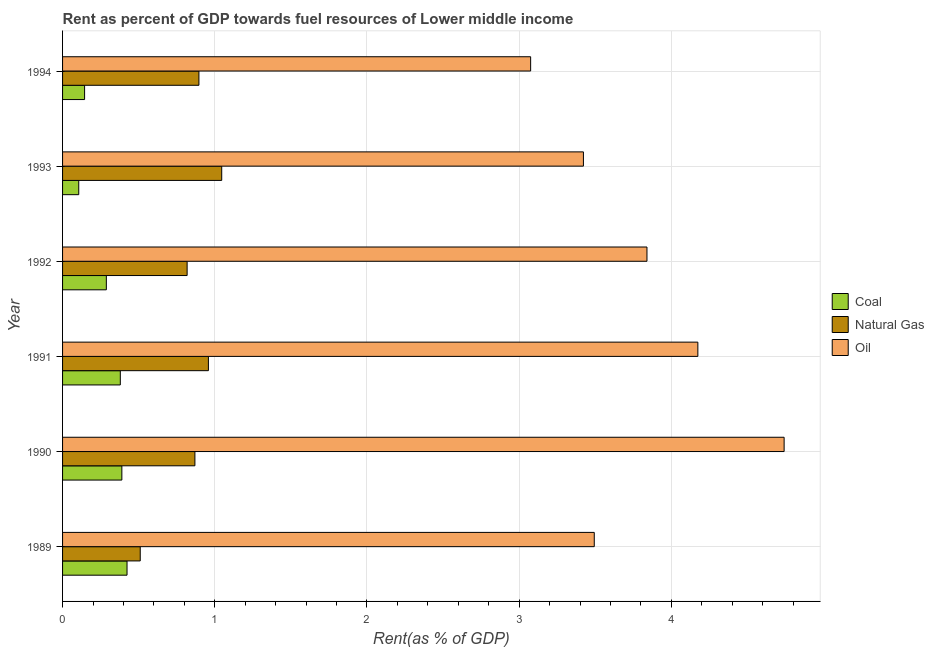In how many cases, is the number of bars for a given year not equal to the number of legend labels?
Keep it short and to the point. 0. What is the rent towards oil in 1992?
Offer a very short reply. 3.84. Across all years, what is the maximum rent towards oil?
Your response must be concise. 4.74. Across all years, what is the minimum rent towards coal?
Your answer should be compact. 0.11. What is the total rent towards coal in the graph?
Offer a terse response. 1.73. What is the difference between the rent towards natural gas in 1991 and that in 1993?
Your answer should be very brief. -0.09. What is the difference between the rent towards coal in 1989 and the rent towards natural gas in 1990?
Offer a very short reply. -0.45. In the year 1993, what is the difference between the rent towards natural gas and rent towards coal?
Provide a short and direct response. 0.94. What is the ratio of the rent towards coal in 1990 to that in 1994?
Your answer should be compact. 2.69. Is the rent towards oil in 1990 less than that in 1992?
Provide a succinct answer. No. Is the difference between the rent towards oil in 1990 and 1993 greater than the difference between the rent towards natural gas in 1990 and 1993?
Make the answer very short. Yes. What is the difference between the highest and the second highest rent towards oil?
Keep it short and to the point. 0.57. What is the difference between the highest and the lowest rent towards oil?
Give a very brief answer. 1.67. Is the sum of the rent towards coal in 1991 and 1992 greater than the maximum rent towards oil across all years?
Your answer should be very brief. No. What does the 1st bar from the top in 1994 represents?
Offer a very short reply. Oil. What does the 2nd bar from the bottom in 1992 represents?
Provide a short and direct response. Natural Gas. Is it the case that in every year, the sum of the rent towards coal and rent towards natural gas is greater than the rent towards oil?
Provide a succinct answer. No. How many bars are there?
Your response must be concise. 18. How many years are there in the graph?
Give a very brief answer. 6. What is the difference between two consecutive major ticks on the X-axis?
Ensure brevity in your answer.  1. Does the graph contain grids?
Give a very brief answer. Yes. Where does the legend appear in the graph?
Offer a terse response. Center right. How are the legend labels stacked?
Your answer should be compact. Vertical. What is the title of the graph?
Your answer should be very brief. Rent as percent of GDP towards fuel resources of Lower middle income. Does "Travel services" appear as one of the legend labels in the graph?
Provide a short and direct response. No. What is the label or title of the X-axis?
Offer a terse response. Rent(as % of GDP). What is the Rent(as % of GDP) in Coal in 1989?
Your answer should be very brief. 0.42. What is the Rent(as % of GDP) in Natural Gas in 1989?
Provide a short and direct response. 0.51. What is the Rent(as % of GDP) in Oil in 1989?
Your answer should be very brief. 3.49. What is the Rent(as % of GDP) in Coal in 1990?
Offer a very short reply. 0.39. What is the Rent(as % of GDP) in Natural Gas in 1990?
Provide a short and direct response. 0.87. What is the Rent(as % of GDP) in Oil in 1990?
Give a very brief answer. 4.74. What is the Rent(as % of GDP) of Coal in 1991?
Your answer should be compact. 0.38. What is the Rent(as % of GDP) of Natural Gas in 1991?
Ensure brevity in your answer.  0.96. What is the Rent(as % of GDP) in Oil in 1991?
Ensure brevity in your answer.  4.17. What is the Rent(as % of GDP) of Coal in 1992?
Give a very brief answer. 0.29. What is the Rent(as % of GDP) in Natural Gas in 1992?
Provide a succinct answer. 0.82. What is the Rent(as % of GDP) of Oil in 1992?
Ensure brevity in your answer.  3.84. What is the Rent(as % of GDP) of Coal in 1993?
Ensure brevity in your answer.  0.11. What is the Rent(as % of GDP) of Natural Gas in 1993?
Your answer should be compact. 1.05. What is the Rent(as % of GDP) in Oil in 1993?
Ensure brevity in your answer.  3.42. What is the Rent(as % of GDP) in Coal in 1994?
Your response must be concise. 0.14. What is the Rent(as % of GDP) in Natural Gas in 1994?
Provide a succinct answer. 0.9. What is the Rent(as % of GDP) of Oil in 1994?
Ensure brevity in your answer.  3.08. Across all years, what is the maximum Rent(as % of GDP) of Coal?
Provide a succinct answer. 0.42. Across all years, what is the maximum Rent(as % of GDP) in Natural Gas?
Provide a short and direct response. 1.05. Across all years, what is the maximum Rent(as % of GDP) of Oil?
Your response must be concise. 4.74. Across all years, what is the minimum Rent(as % of GDP) of Coal?
Offer a very short reply. 0.11. Across all years, what is the minimum Rent(as % of GDP) in Natural Gas?
Your response must be concise. 0.51. Across all years, what is the minimum Rent(as % of GDP) of Oil?
Your response must be concise. 3.08. What is the total Rent(as % of GDP) of Coal in the graph?
Ensure brevity in your answer.  1.73. What is the total Rent(as % of GDP) in Natural Gas in the graph?
Give a very brief answer. 5.1. What is the total Rent(as % of GDP) in Oil in the graph?
Offer a terse response. 22.75. What is the difference between the Rent(as % of GDP) in Coal in 1989 and that in 1990?
Offer a terse response. 0.03. What is the difference between the Rent(as % of GDP) of Natural Gas in 1989 and that in 1990?
Give a very brief answer. -0.36. What is the difference between the Rent(as % of GDP) of Oil in 1989 and that in 1990?
Make the answer very short. -1.25. What is the difference between the Rent(as % of GDP) in Coal in 1989 and that in 1991?
Provide a short and direct response. 0.04. What is the difference between the Rent(as % of GDP) of Natural Gas in 1989 and that in 1991?
Offer a very short reply. -0.45. What is the difference between the Rent(as % of GDP) of Oil in 1989 and that in 1991?
Provide a short and direct response. -0.68. What is the difference between the Rent(as % of GDP) in Coal in 1989 and that in 1992?
Offer a terse response. 0.14. What is the difference between the Rent(as % of GDP) of Natural Gas in 1989 and that in 1992?
Keep it short and to the point. -0.31. What is the difference between the Rent(as % of GDP) in Oil in 1989 and that in 1992?
Provide a short and direct response. -0.35. What is the difference between the Rent(as % of GDP) of Coal in 1989 and that in 1993?
Ensure brevity in your answer.  0.32. What is the difference between the Rent(as % of GDP) in Natural Gas in 1989 and that in 1993?
Ensure brevity in your answer.  -0.54. What is the difference between the Rent(as % of GDP) of Oil in 1989 and that in 1993?
Provide a short and direct response. 0.07. What is the difference between the Rent(as % of GDP) in Coal in 1989 and that in 1994?
Your answer should be very brief. 0.28. What is the difference between the Rent(as % of GDP) of Natural Gas in 1989 and that in 1994?
Your answer should be very brief. -0.39. What is the difference between the Rent(as % of GDP) in Oil in 1989 and that in 1994?
Offer a very short reply. 0.42. What is the difference between the Rent(as % of GDP) in Coal in 1990 and that in 1991?
Ensure brevity in your answer.  0.01. What is the difference between the Rent(as % of GDP) in Natural Gas in 1990 and that in 1991?
Your answer should be very brief. -0.09. What is the difference between the Rent(as % of GDP) in Oil in 1990 and that in 1991?
Provide a succinct answer. 0.57. What is the difference between the Rent(as % of GDP) of Coal in 1990 and that in 1992?
Make the answer very short. 0.1. What is the difference between the Rent(as % of GDP) of Natural Gas in 1990 and that in 1992?
Ensure brevity in your answer.  0.05. What is the difference between the Rent(as % of GDP) in Oil in 1990 and that in 1992?
Your response must be concise. 0.9. What is the difference between the Rent(as % of GDP) of Coal in 1990 and that in 1993?
Provide a succinct answer. 0.28. What is the difference between the Rent(as % of GDP) in Natural Gas in 1990 and that in 1993?
Your response must be concise. -0.18. What is the difference between the Rent(as % of GDP) of Oil in 1990 and that in 1993?
Provide a short and direct response. 1.32. What is the difference between the Rent(as % of GDP) of Coal in 1990 and that in 1994?
Offer a terse response. 0.24. What is the difference between the Rent(as % of GDP) of Natural Gas in 1990 and that in 1994?
Offer a very short reply. -0.03. What is the difference between the Rent(as % of GDP) of Oil in 1990 and that in 1994?
Provide a succinct answer. 1.67. What is the difference between the Rent(as % of GDP) of Coal in 1991 and that in 1992?
Provide a short and direct response. 0.09. What is the difference between the Rent(as % of GDP) in Natural Gas in 1991 and that in 1992?
Offer a very short reply. 0.14. What is the difference between the Rent(as % of GDP) in Oil in 1991 and that in 1992?
Offer a very short reply. 0.33. What is the difference between the Rent(as % of GDP) of Coal in 1991 and that in 1993?
Offer a very short reply. 0.27. What is the difference between the Rent(as % of GDP) in Natural Gas in 1991 and that in 1993?
Offer a terse response. -0.09. What is the difference between the Rent(as % of GDP) in Oil in 1991 and that in 1993?
Keep it short and to the point. 0.75. What is the difference between the Rent(as % of GDP) of Coal in 1991 and that in 1994?
Make the answer very short. 0.23. What is the difference between the Rent(as % of GDP) in Natural Gas in 1991 and that in 1994?
Ensure brevity in your answer.  0.06. What is the difference between the Rent(as % of GDP) of Oil in 1991 and that in 1994?
Give a very brief answer. 1.1. What is the difference between the Rent(as % of GDP) of Coal in 1992 and that in 1993?
Provide a succinct answer. 0.18. What is the difference between the Rent(as % of GDP) of Natural Gas in 1992 and that in 1993?
Your response must be concise. -0.23. What is the difference between the Rent(as % of GDP) in Oil in 1992 and that in 1993?
Your answer should be very brief. 0.42. What is the difference between the Rent(as % of GDP) of Coal in 1992 and that in 1994?
Make the answer very short. 0.14. What is the difference between the Rent(as % of GDP) in Natural Gas in 1992 and that in 1994?
Make the answer very short. -0.08. What is the difference between the Rent(as % of GDP) in Oil in 1992 and that in 1994?
Your answer should be very brief. 0.76. What is the difference between the Rent(as % of GDP) in Coal in 1993 and that in 1994?
Make the answer very short. -0.04. What is the difference between the Rent(as % of GDP) of Natural Gas in 1993 and that in 1994?
Offer a terse response. 0.15. What is the difference between the Rent(as % of GDP) of Oil in 1993 and that in 1994?
Make the answer very short. 0.35. What is the difference between the Rent(as % of GDP) of Coal in 1989 and the Rent(as % of GDP) of Natural Gas in 1990?
Provide a succinct answer. -0.45. What is the difference between the Rent(as % of GDP) in Coal in 1989 and the Rent(as % of GDP) in Oil in 1990?
Provide a succinct answer. -4.32. What is the difference between the Rent(as % of GDP) in Natural Gas in 1989 and the Rent(as % of GDP) in Oil in 1990?
Your answer should be very brief. -4.23. What is the difference between the Rent(as % of GDP) of Coal in 1989 and the Rent(as % of GDP) of Natural Gas in 1991?
Provide a succinct answer. -0.53. What is the difference between the Rent(as % of GDP) of Coal in 1989 and the Rent(as % of GDP) of Oil in 1991?
Keep it short and to the point. -3.75. What is the difference between the Rent(as % of GDP) in Natural Gas in 1989 and the Rent(as % of GDP) in Oil in 1991?
Your answer should be very brief. -3.66. What is the difference between the Rent(as % of GDP) in Coal in 1989 and the Rent(as % of GDP) in Natural Gas in 1992?
Your answer should be very brief. -0.39. What is the difference between the Rent(as % of GDP) of Coal in 1989 and the Rent(as % of GDP) of Oil in 1992?
Offer a terse response. -3.42. What is the difference between the Rent(as % of GDP) of Natural Gas in 1989 and the Rent(as % of GDP) of Oil in 1992?
Your answer should be compact. -3.33. What is the difference between the Rent(as % of GDP) in Coal in 1989 and the Rent(as % of GDP) in Natural Gas in 1993?
Your answer should be compact. -0.62. What is the difference between the Rent(as % of GDP) in Coal in 1989 and the Rent(as % of GDP) in Oil in 1993?
Offer a very short reply. -3. What is the difference between the Rent(as % of GDP) of Natural Gas in 1989 and the Rent(as % of GDP) of Oil in 1993?
Offer a very short reply. -2.91. What is the difference between the Rent(as % of GDP) of Coal in 1989 and the Rent(as % of GDP) of Natural Gas in 1994?
Your answer should be compact. -0.47. What is the difference between the Rent(as % of GDP) of Coal in 1989 and the Rent(as % of GDP) of Oil in 1994?
Offer a very short reply. -2.65. What is the difference between the Rent(as % of GDP) in Natural Gas in 1989 and the Rent(as % of GDP) in Oil in 1994?
Offer a very short reply. -2.56. What is the difference between the Rent(as % of GDP) in Coal in 1990 and the Rent(as % of GDP) in Natural Gas in 1991?
Your answer should be compact. -0.57. What is the difference between the Rent(as % of GDP) of Coal in 1990 and the Rent(as % of GDP) of Oil in 1991?
Make the answer very short. -3.78. What is the difference between the Rent(as % of GDP) of Natural Gas in 1990 and the Rent(as % of GDP) of Oil in 1991?
Ensure brevity in your answer.  -3.3. What is the difference between the Rent(as % of GDP) of Coal in 1990 and the Rent(as % of GDP) of Natural Gas in 1992?
Ensure brevity in your answer.  -0.43. What is the difference between the Rent(as % of GDP) in Coal in 1990 and the Rent(as % of GDP) in Oil in 1992?
Your answer should be compact. -3.45. What is the difference between the Rent(as % of GDP) of Natural Gas in 1990 and the Rent(as % of GDP) of Oil in 1992?
Keep it short and to the point. -2.97. What is the difference between the Rent(as % of GDP) of Coal in 1990 and the Rent(as % of GDP) of Natural Gas in 1993?
Keep it short and to the point. -0.66. What is the difference between the Rent(as % of GDP) of Coal in 1990 and the Rent(as % of GDP) of Oil in 1993?
Your answer should be compact. -3.03. What is the difference between the Rent(as % of GDP) in Natural Gas in 1990 and the Rent(as % of GDP) in Oil in 1993?
Give a very brief answer. -2.55. What is the difference between the Rent(as % of GDP) of Coal in 1990 and the Rent(as % of GDP) of Natural Gas in 1994?
Your answer should be compact. -0.51. What is the difference between the Rent(as % of GDP) in Coal in 1990 and the Rent(as % of GDP) in Oil in 1994?
Give a very brief answer. -2.69. What is the difference between the Rent(as % of GDP) of Natural Gas in 1990 and the Rent(as % of GDP) of Oil in 1994?
Offer a terse response. -2.21. What is the difference between the Rent(as % of GDP) of Coal in 1991 and the Rent(as % of GDP) of Natural Gas in 1992?
Provide a succinct answer. -0.44. What is the difference between the Rent(as % of GDP) in Coal in 1991 and the Rent(as % of GDP) in Oil in 1992?
Ensure brevity in your answer.  -3.46. What is the difference between the Rent(as % of GDP) in Natural Gas in 1991 and the Rent(as % of GDP) in Oil in 1992?
Offer a very short reply. -2.88. What is the difference between the Rent(as % of GDP) of Coal in 1991 and the Rent(as % of GDP) of Natural Gas in 1993?
Your answer should be very brief. -0.67. What is the difference between the Rent(as % of GDP) of Coal in 1991 and the Rent(as % of GDP) of Oil in 1993?
Provide a succinct answer. -3.04. What is the difference between the Rent(as % of GDP) of Natural Gas in 1991 and the Rent(as % of GDP) of Oil in 1993?
Your response must be concise. -2.46. What is the difference between the Rent(as % of GDP) of Coal in 1991 and the Rent(as % of GDP) of Natural Gas in 1994?
Offer a terse response. -0.52. What is the difference between the Rent(as % of GDP) in Coal in 1991 and the Rent(as % of GDP) in Oil in 1994?
Your answer should be very brief. -2.7. What is the difference between the Rent(as % of GDP) of Natural Gas in 1991 and the Rent(as % of GDP) of Oil in 1994?
Keep it short and to the point. -2.12. What is the difference between the Rent(as % of GDP) of Coal in 1992 and the Rent(as % of GDP) of Natural Gas in 1993?
Make the answer very short. -0.76. What is the difference between the Rent(as % of GDP) in Coal in 1992 and the Rent(as % of GDP) in Oil in 1993?
Provide a succinct answer. -3.13. What is the difference between the Rent(as % of GDP) in Natural Gas in 1992 and the Rent(as % of GDP) in Oil in 1993?
Ensure brevity in your answer.  -2.6. What is the difference between the Rent(as % of GDP) in Coal in 1992 and the Rent(as % of GDP) in Natural Gas in 1994?
Your answer should be very brief. -0.61. What is the difference between the Rent(as % of GDP) of Coal in 1992 and the Rent(as % of GDP) of Oil in 1994?
Offer a terse response. -2.79. What is the difference between the Rent(as % of GDP) in Natural Gas in 1992 and the Rent(as % of GDP) in Oil in 1994?
Give a very brief answer. -2.26. What is the difference between the Rent(as % of GDP) in Coal in 1993 and the Rent(as % of GDP) in Natural Gas in 1994?
Make the answer very short. -0.79. What is the difference between the Rent(as % of GDP) in Coal in 1993 and the Rent(as % of GDP) in Oil in 1994?
Give a very brief answer. -2.97. What is the difference between the Rent(as % of GDP) in Natural Gas in 1993 and the Rent(as % of GDP) in Oil in 1994?
Ensure brevity in your answer.  -2.03. What is the average Rent(as % of GDP) of Coal per year?
Offer a terse response. 0.29. What is the average Rent(as % of GDP) in Natural Gas per year?
Keep it short and to the point. 0.85. What is the average Rent(as % of GDP) in Oil per year?
Keep it short and to the point. 3.79. In the year 1989, what is the difference between the Rent(as % of GDP) of Coal and Rent(as % of GDP) of Natural Gas?
Offer a very short reply. -0.09. In the year 1989, what is the difference between the Rent(as % of GDP) in Coal and Rent(as % of GDP) in Oil?
Provide a short and direct response. -3.07. In the year 1989, what is the difference between the Rent(as % of GDP) in Natural Gas and Rent(as % of GDP) in Oil?
Offer a terse response. -2.98. In the year 1990, what is the difference between the Rent(as % of GDP) in Coal and Rent(as % of GDP) in Natural Gas?
Ensure brevity in your answer.  -0.48. In the year 1990, what is the difference between the Rent(as % of GDP) of Coal and Rent(as % of GDP) of Oil?
Provide a short and direct response. -4.35. In the year 1990, what is the difference between the Rent(as % of GDP) in Natural Gas and Rent(as % of GDP) in Oil?
Your response must be concise. -3.87. In the year 1991, what is the difference between the Rent(as % of GDP) of Coal and Rent(as % of GDP) of Natural Gas?
Your answer should be very brief. -0.58. In the year 1991, what is the difference between the Rent(as % of GDP) in Coal and Rent(as % of GDP) in Oil?
Provide a succinct answer. -3.79. In the year 1991, what is the difference between the Rent(as % of GDP) of Natural Gas and Rent(as % of GDP) of Oil?
Make the answer very short. -3.22. In the year 1992, what is the difference between the Rent(as % of GDP) in Coal and Rent(as % of GDP) in Natural Gas?
Offer a very short reply. -0.53. In the year 1992, what is the difference between the Rent(as % of GDP) in Coal and Rent(as % of GDP) in Oil?
Provide a succinct answer. -3.55. In the year 1992, what is the difference between the Rent(as % of GDP) of Natural Gas and Rent(as % of GDP) of Oil?
Ensure brevity in your answer.  -3.02. In the year 1993, what is the difference between the Rent(as % of GDP) of Coal and Rent(as % of GDP) of Natural Gas?
Make the answer very short. -0.94. In the year 1993, what is the difference between the Rent(as % of GDP) in Coal and Rent(as % of GDP) in Oil?
Give a very brief answer. -3.32. In the year 1993, what is the difference between the Rent(as % of GDP) in Natural Gas and Rent(as % of GDP) in Oil?
Make the answer very short. -2.38. In the year 1994, what is the difference between the Rent(as % of GDP) of Coal and Rent(as % of GDP) of Natural Gas?
Provide a succinct answer. -0.75. In the year 1994, what is the difference between the Rent(as % of GDP) in Coal and Rent(as % of GDP) in Oil?
Offer a very short reply. -2.93. In the year 1994, what is the difference between the Rent(as % of GDP) in Natural Gas and Rent(as % of GDP) in Oil?
Make the answer very short. -2.18. What is the ratio of the Rent(as % of GDP) of Coal in 1989 to that in 1990?
Make the answer very short. 1.09. What is the ratio of the Rent(as % of GDP) of Natural Gas in 1989 to that in 1990?
Ensure brevity in your answer.  0.59. What is the ratio of the Rent(as % of GDP) in Oil in 1989 to that in 1990?
Make the answer very short. 0.74. What is the ratio of the Rent(as % of GDP) in Coal in 1989 to that in 1991?
Offer a terse response. 1.12. What is the ratio of the Rent(as % of GDP) in Natural Gas in 1989 to that in 1991?
Make the answer very short. 0.53. What is the ratio of the Rent(as % of GDP) of Oil in 1989 to that in 1991?
Offer a terse response. 0.84. What is the ratio of the Rent(as % of GDP) of Coal in 1989 to that in 1992?
Your answer should be very brief. 1.47. What is the ratio of the Rent(as % of GDP) of Natural Gas in 1989 to that in 1992?
Provide a succinct answer. 0.62. What is the ratio of the Rent(as % of GDP) of Oil in 1989 to that in 1992?
Offer a terse response. 0.91. What is the ratio of the Rent(as % of GDP) in Coal in 1989 to that in 1993?
Make the answer very short. 3.98. What is the ratio of the Rent(as % of GDP) of Natural Gas in 1989 to that in 1993?
Provide a succinct answer. 0.49. What is the ratio of the Rent(as % of GDP) of Oil in 1989 to that in 1993?
Your answer should be compact. 1.02. What is the ratio of the Rent(as % of GDP) in Coal in 1989 to that in 1994?
Make the answer very short. 2.93. What is the ratio of the Rent(as % of GDP) of Natural Gas in 1989 to that in 1994?
Offer a very short reply. 0.57. What is the ratio of the Rent(as % of GDP) of Oil in 1989 to that in 1994?
Keep it short and to the point. 1.14. What is the ratio of the Rent(as % of GDP) in Coal in 1990 to that in 1991?
Your response must be concise. 1.03. What is the ratio of the Rent(as % of GDP) of Natural Gas in 1990 to that in 1991?
Give a very brief answer. 0.91. What is the ratio of the Rent(as % of GDP) in Oil in 1990 to that in 1991?
Offer a very short reply. 1.14. What is the ratio of the Rent(as % of GDP) of Coal in 1990 to that in 1992?
Ensure brevity in your answer.  1.35. What is the ratio of the Rent(as % of GDP) of Natural Gas in 1990 to that in 1992?
Offer a very short reply. 1.06. What is the ratio of the Rent(as % of GDP) of Oil in 1990 to that in 1992?
Provide a short and direct response. 1.23. What is the ratio of the Rent(as % of GDP) of Coal in 1990 to that in 1993?
Offer a very short reply. 3.66. What is the ratio of the Rent(as % of GDP) in Natural Gas in 1990 to that in 1993?
Your answer should be very brief. 0.83. What is the ratio of the Rent(as % of GDP) of Oil in 1990 to that in 1993?
Provide a succinct answer. 1.39. What is the ratio of the Rent(as % of GDP) of Coal in 1990 to that in 1994?
Provide a short and direct response. 2.69. What is the ratio of the Rent(as % of GDP) of Natural Gas in 1990 to that in 1994?
Offer a very short reply. 0.97. What is the ratio of the Rent(as % of GDP) in Oil in 1990 to that in 1994?
Make the answer very short. 1.54. What is the ratio of the Rent(as % of GDP) of Coal in 1991 to that in 1992?
Provide a succinct answer. 1.32. What is the ratio of the Rent(as % of GDP) of Natural Gas in 1991 to that in 1992?
Ensure brevity in your answer.  1.17. What is the ratio of the Rent(as % of GDP) of Oil in 1991 to that in 1992?
Your answer should be very brief. 1.09. What is the ratio of the Rent(as % of GDP) in Coal in 1991 to that in 1993?
Ensure brevity in your answer.  3.57. What is the ratio of the Rent(as % of GDP) of Natural Gas in 1991 to that in 1993?
Your answer should be very brief. 0.92. What is the ratio of the Rent(as % of GDP) in Oil in 1991 to that in 1993?
Provide a succinct answer. 1.22. What is the ratio of the Rent(as % of GDP) of Coal in 1991 to that in 1994?
Your response must be concise. 2.62. What is the ratio of the Rent(as % of GDP) in Natural Gas in 1991 to that in 1994?
Keep it short and to the point. 1.07. What is the ratio of the Rent(as % of GDP) of Oil in 1991 to that in 1994?
Offer a terse response. 1.36. What is the ratio of the Rent(as % of GDP) of Coal in 1992 to that in 1993?
Provide a succinct answer. 2.71. What is the ratio of the Rent(as % of GDP) of Natural Gas in 1992 to that in 1993?
Ensure brevity in your answer.  0.78. What is the ratio of the Rent(as % of GDP) in Oil in 1992 to that in 1993?
Offer a very short reply. 1.12. What is the ratio of the Rent(as % of GDP) of Coal in 1992 to that in 1994?
Ensure brevity in your answer.  1.99. What is the ratio of the Rent(as % of GDP) of Natural Gas in 1992 to that in 1994?
Provide a succinct answer. 0.91. What is the ratio of the Rent(as % of GDP) in Oil in 1992 to that in 1994?
Provide a succinct answer. 1.25. What is the ratio of the Rent(as % of GDP) in Coal in 1993 to that in 1994?
Give a very brief answer. 0.73. What is the ratio of the Rent(as % of GDP) in Natural Gas in 1993 to that in 1994?
Give a very brief answer. 1.17. What is the ratio of the Rent(as % of GDP) of Oil in 1993 to that in 1994?
Make the answer very short. 1.11. What is the difference between the highest and the second highest Rent(as % of GDP) in Coal?
Your answer should be very brief. 0.03. What is the difference between the highest and the second highest Rent(as % of GDP) of Natural Gas?
Offer a terse response. 0.09. What is the difference between the highest and the second highest Rent(as % of GDP) in Oil?
Your answer should be compact. 0.57. What is the difference between the highest and the lowest Rent(as % of GDP) of Coal?
Offer a terse response. 0.32. What is the difference between the highest and the lowest Rent(as % of GDP) of Natural Gas?
Your answer should be compact. 0.54. What is the difference between the highest and the lowest Rent(as % of GDP) of Oil?
Offer a terse response. 1.67. 